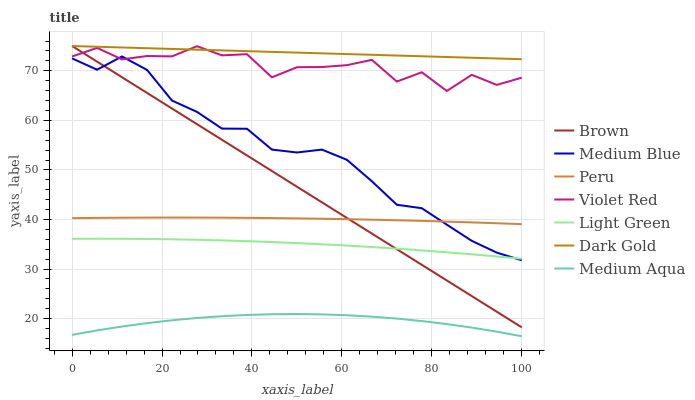Does Medium Aqua have the minimum area under the curve?
Answer yes or no. Yes. Does Dark Gold have the maximum area under the curve?
Answer yes or no. Yes. Does Violet Red have the minimum area under the curve?
Answer yes or no. No. Does Violet Red have the maximum area under the curve?
Answer yes or no. No. Is Brown the smoothest?
Answer yes or no. Yes. Is Violet Red the roughest?
Answer yes or no. Yes. Is Peru the smoothest?
Answer yes or no. No. Is Peru the roughest?
Answer yes or no. No. Does Medium Aqua have the lowest value?
Answer yes or no. Yes. Does Violet Red have the lowest value?
Answer yes or no. No. Does Dark Gold have the highest value?
Answer yes or no. Yes. Does Violet Red have the highest value?
Answer yes or no. No. Is Peru less than Violet Red?
Answer yes or no. Yes. Is Medium Blue greater than Medium Aqua?
Answer yes or no. Yes. Does Violet Red intersect Dark Gold?
Answer yes or no. Yes. Is Violet Red less than Dark Gold?
Answer yes or no. No. Is Violet Red greater than Dark Gold?
Answer yes or no. No. Does Peru intersect Violet Red?
Answer yes or no. No. 